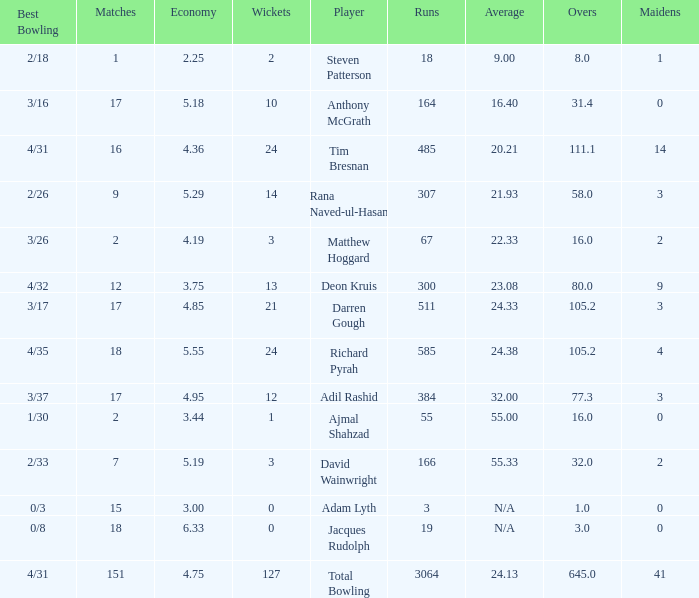What is the lowest Overs with a Run that is 18? 8.0. 